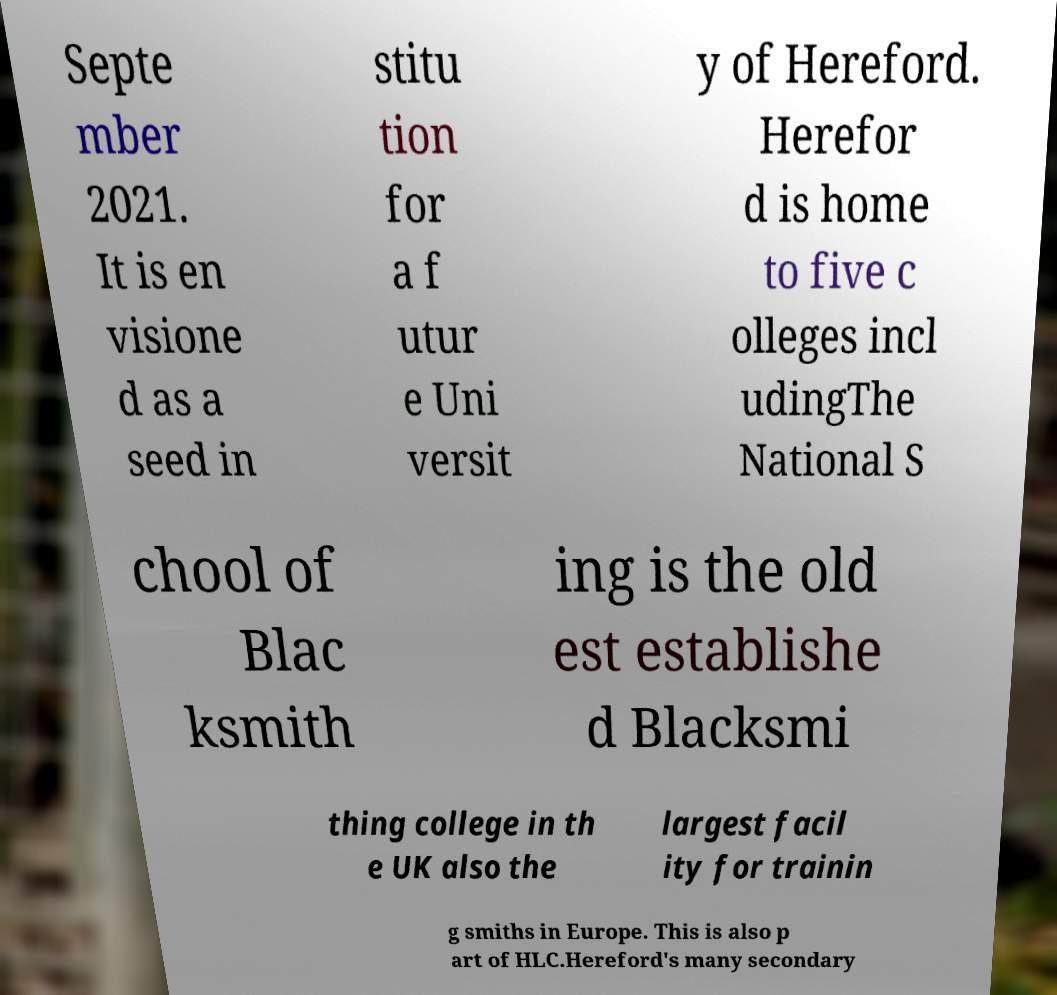Can you read and provide the text displayed in the image?This photo seems to have some interesting text. Can you extract and type it out for me? Septe mber 2021. It is en visione d as a seed in stitu tion for a f utur e Uni versit y of Hereford. Herefor d is home to five c olleges incl udingThe National S chool of Blac ksmith ing is the old est establishe d Blacksmi thing college in th e UK also the largest facil ity for trainin g smiths in Europe. This is also p art of HLC.Hereford's many secondary 